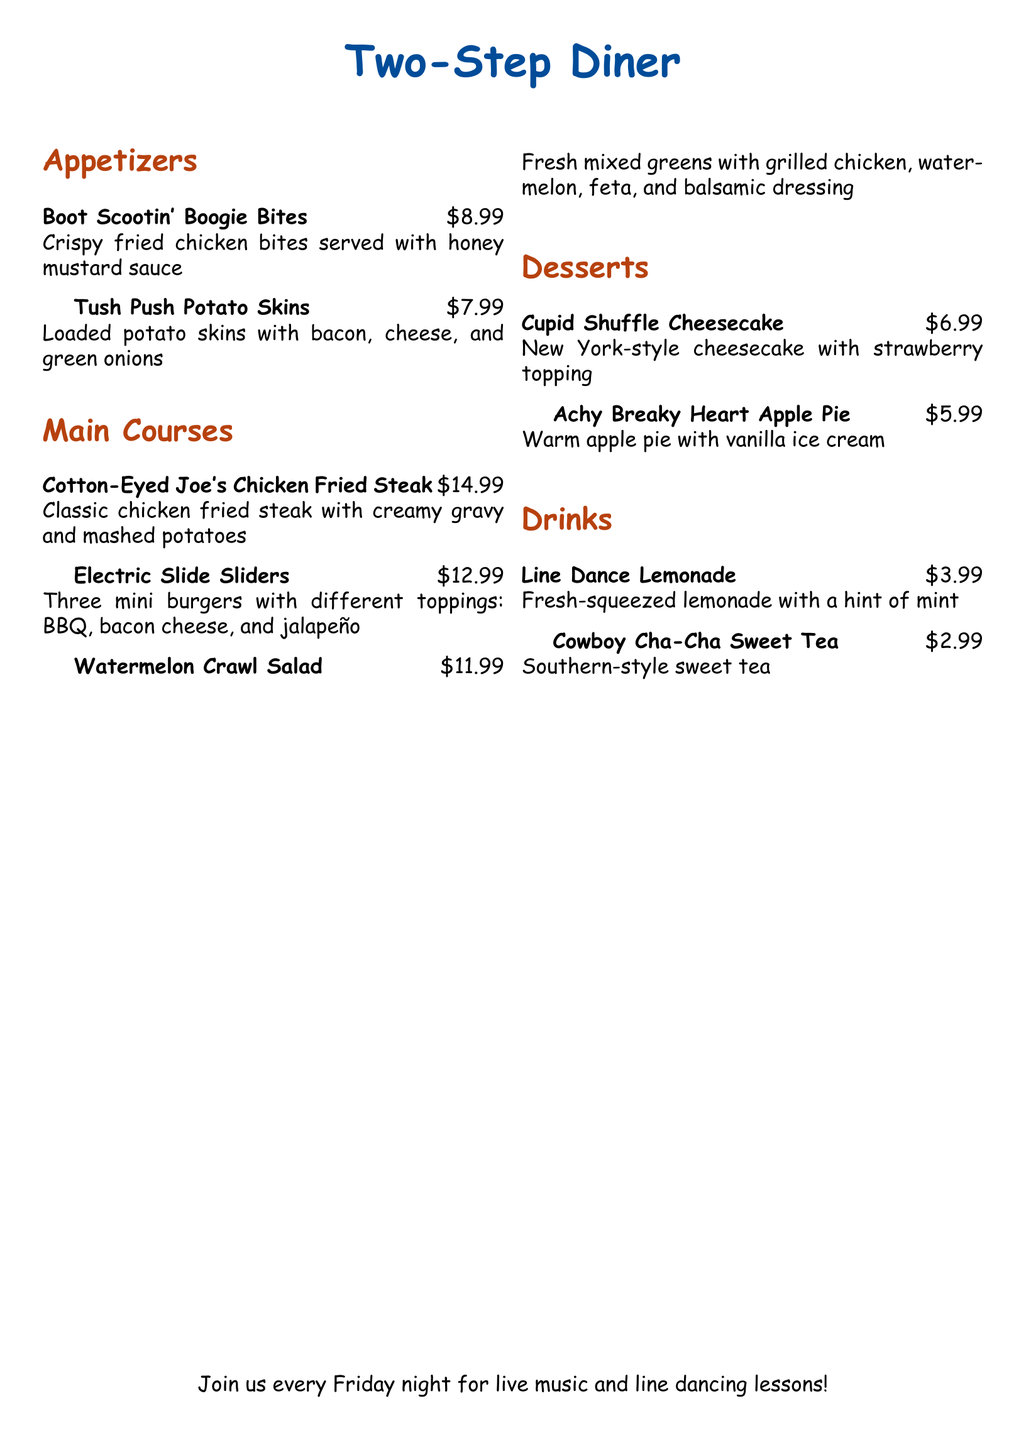what is the name of the diner? The name is presented at the top of the document, highlighting the theme of the diner.
Answer: Two-Step Diner how much do Boot Scootin' Boogie Bites cost? The price for this appetizer is stated alongside its name in the document.
Answer: $8.99 what type of salad is offered? The menu lists a specific salad that aligns with the country theme.
Answer: Watermelon Crawl Salad what dessert features apple pie? The dessert section specifically mentions a pie related to a popular line dance.
Answer: Achy Breaky Heart Apple Pie which drink is southern-style? The drink description highlights its connection to a traditional southern beverage.
Answer: Cowboy Cha-Cha Sweet Tea how many sliders are included in the Electric Slide Sliders? The menu specifies the quantity of sliders served as part of the dish.
Answer: Three what is the main ingredient in Cupid Shuffle Cheesecake? The description provides insight into the type of cheesecake served at the diner.
Answer: New York-style cheesecake on which night are line dancing lessons available? The announcement at the bottom of the document clearly states the day for special events.
Answer: Friday 